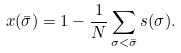<formula> <loc_0><loc_0><loc_500><loc_500>x ( \bar { \sigma } ) = 1 - \frac { 1 } { N } \sum _ { \sigma < \bar { \sigma } } s ( \sigma ) .</formula> 